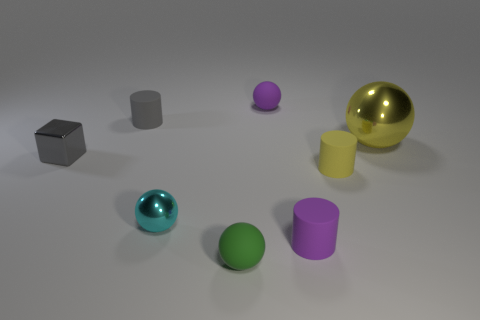Subtract all gray cylinders. How many cylinders are left? 2 Subtract all purple matte spheres. How many spheres are left? 3 Subtract all red cubes. How many yellow cylinders are left? 1 Subtract all yellow spheres. Subtract all yellow rubber things. How many objects are left? 6 Add 1 cyan things. How many cyan things are left? 2 Add 3 tiny gray rubber cylinders. How many tiny gray rubber cylinders exist? 4 Add 1 small purple rubber spheres. How many objects exist? 9 Subtract 1 purple cylinders. How many objects are left? 7 Subtract all cylinders. How many objects are left? 5 Subtract 2 cylinders. How many cylinders are left? 1 